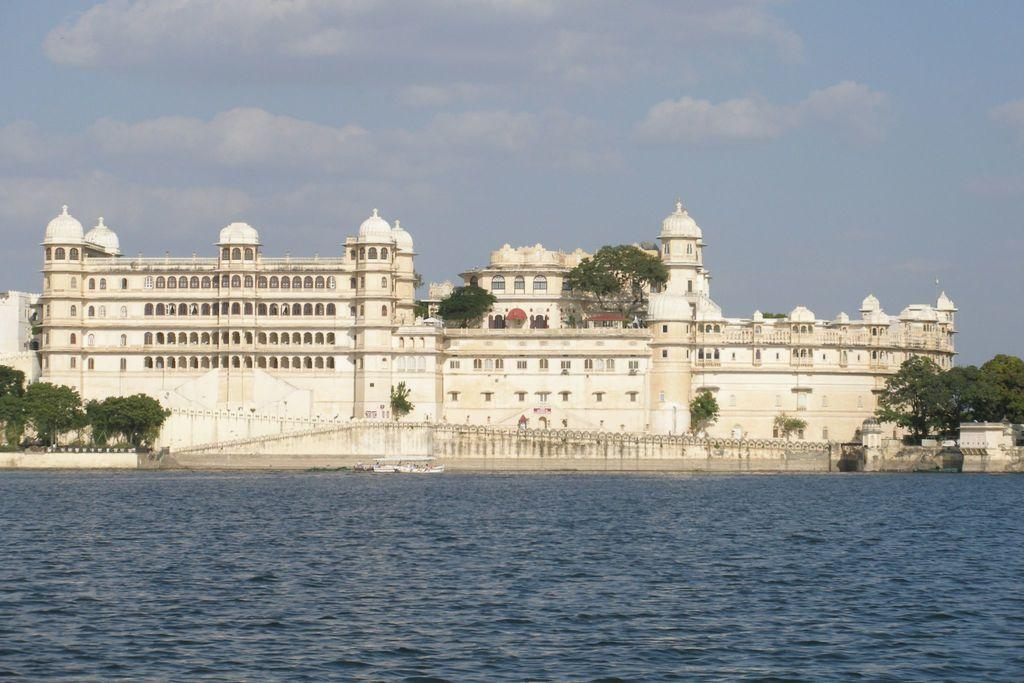What is in the foreground of the image? There is a water body in the foreground of the image. What is visible in the background of the image? There is a building and trees in the background of the image. How would you describe the sky in the image? The sky is cloudy in the image. What type of ornament is hanging from the trees in the image? There are no ornaments hanging from the trees in the image; only trees and a building are visible in the background. How does the stew taste in the image? There is no stew present in the image, so it cannot be tasted or described. 